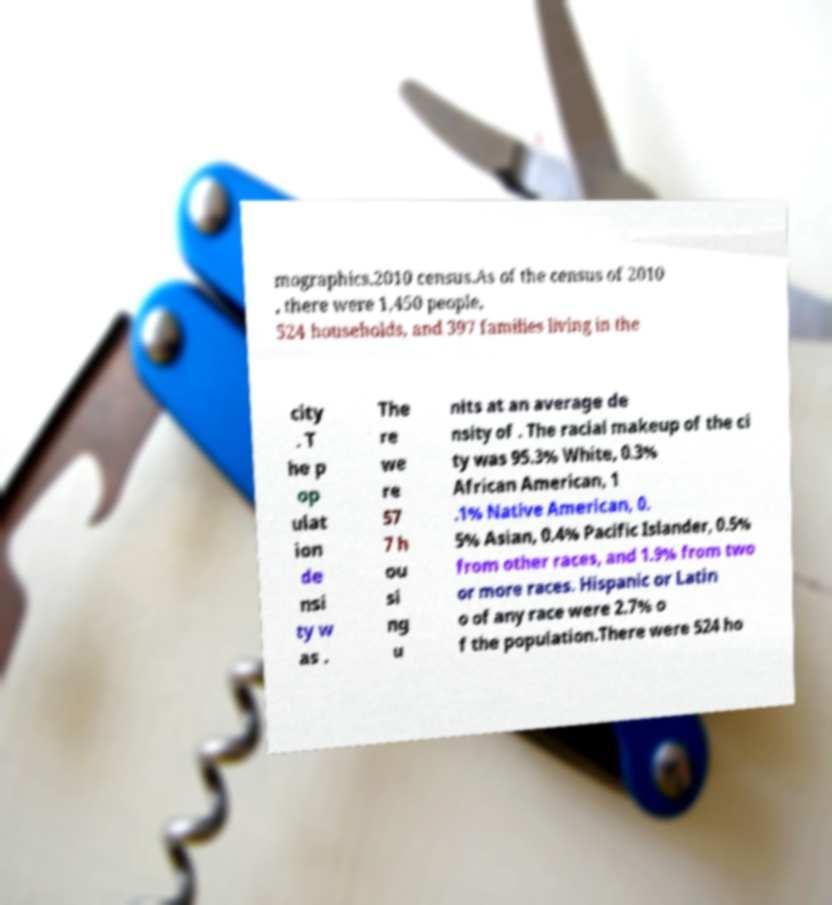Can you read and provide the text displayed in the image?This photo seems to have some interesting text. Can you extract and type it out for me? mographics.2010 census.As of the census of 2010 , there were 1,450 people, 524 households, and 397 families living in the city . T he p op ulat ion de nsi ty w as . The re we re 57 7 h ou si ng u nits at an average de nsity of . The racial makeup of the ci ty was 95.3% White, 0.3% African American, 1 .1% Native American, 0. 5% Asian, 0.4% Pacific Islander, 0.5% from other races, and 1.9% from two or more races. Hispanic or Latin o of any race were 2.7% o f the population.There were 524 ho 